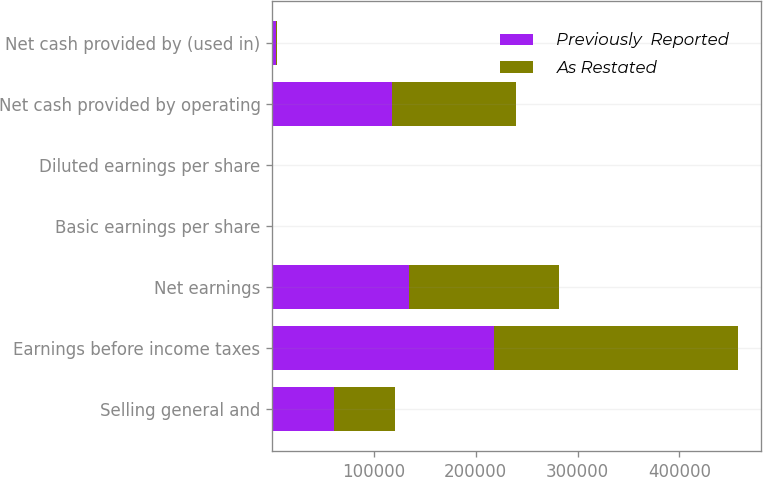Convert chart to OTSL. <chart><loc_0><loc_0><loc_500><loc_500><stacked_bar_chart><ecel><fcel>Selling general and<fcel>Earnings before income taxes<fcel>Net earnings<fcel>Basic earnings per share<fcel>Diluted earnings per share<fcel>Net cash provided by operating<fcel>Net cash provided by (used in)<nl><fcel>Previously  Reported<fcel>60364<fcel>217601<fcel>134220<fcel>0.64<fcel>0.63<fcel>117513<fcel>3215<nl><fcel>As Restated<fcel>60364<fcel>239983<fcel>148055<fcel>0.71<fcel>0.7<fcel>122295<fcel>1567<nl></chart> 